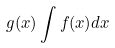<formula> <loc_0><loc_0><loc_500><loc_500>g ( x ) \int f ( x ) d x</formula> 